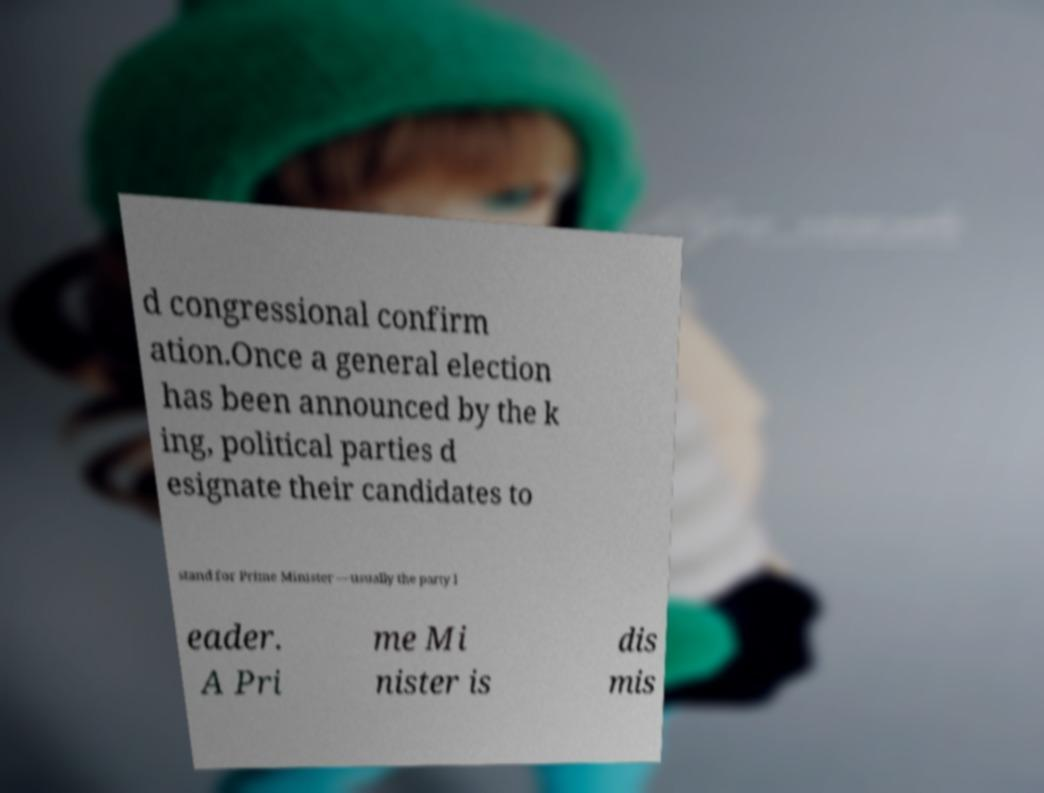For documentation purposes, I need the text within this image transcribed. Could you provide that? d congressional confirm ation.Once a general election has been announced by the k ing, political parties d esignate their candidates to stand for Prime Minister —usually the party l eader. A Pri me Mi nister is dis mis 